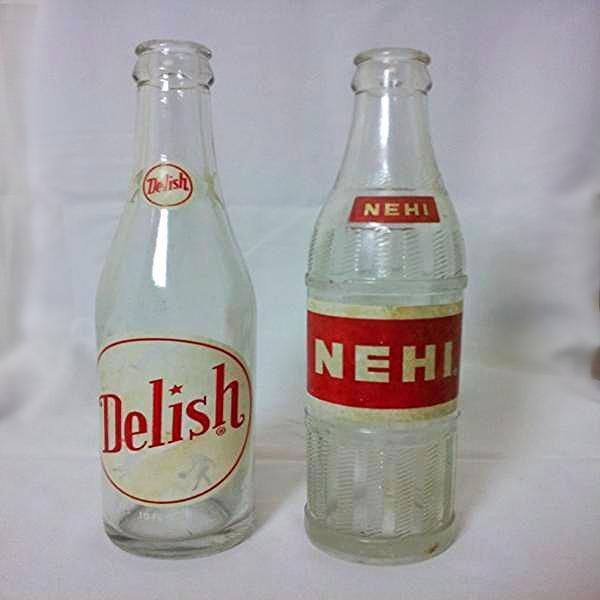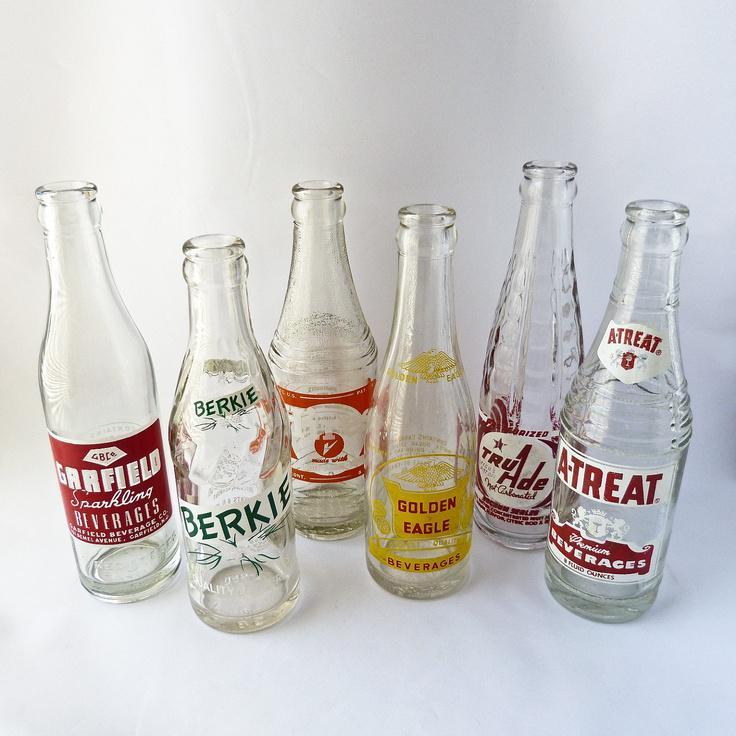The first image is the image on the left, the second image is the image on the right. Considering the images on both sides, is "The left image contains a staggered line of five glass bottles, and the right image contains a straighter row of four bottles." valid? Answer yes or no. No. The first image is the image on the left, the second image is the image on the right. For the images displayed, is the sentence "There are four bottles in one image and five in the other." factually correct? Answer yes or no. No. 